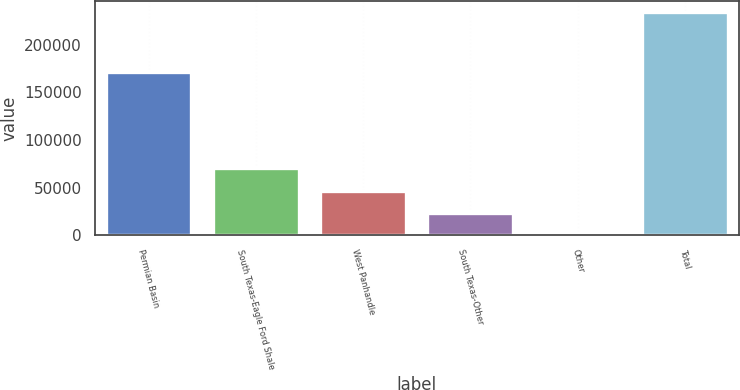Convert chart to OTSL. <chart><loc_0><loc_0><loc_500><loc_500><bar_chart><fcel>Permian Basin<fcel>South Texas-Eagle Ford Shale<fcel>West Panhandle<fcel>South Texas-Other<fcel>Other<fcel>Total<nl><fcel>170827<fcel>70159.6<fcel>46776.4<fcel>23393.2<fcel>10<fcel>233842<nl></chart> 